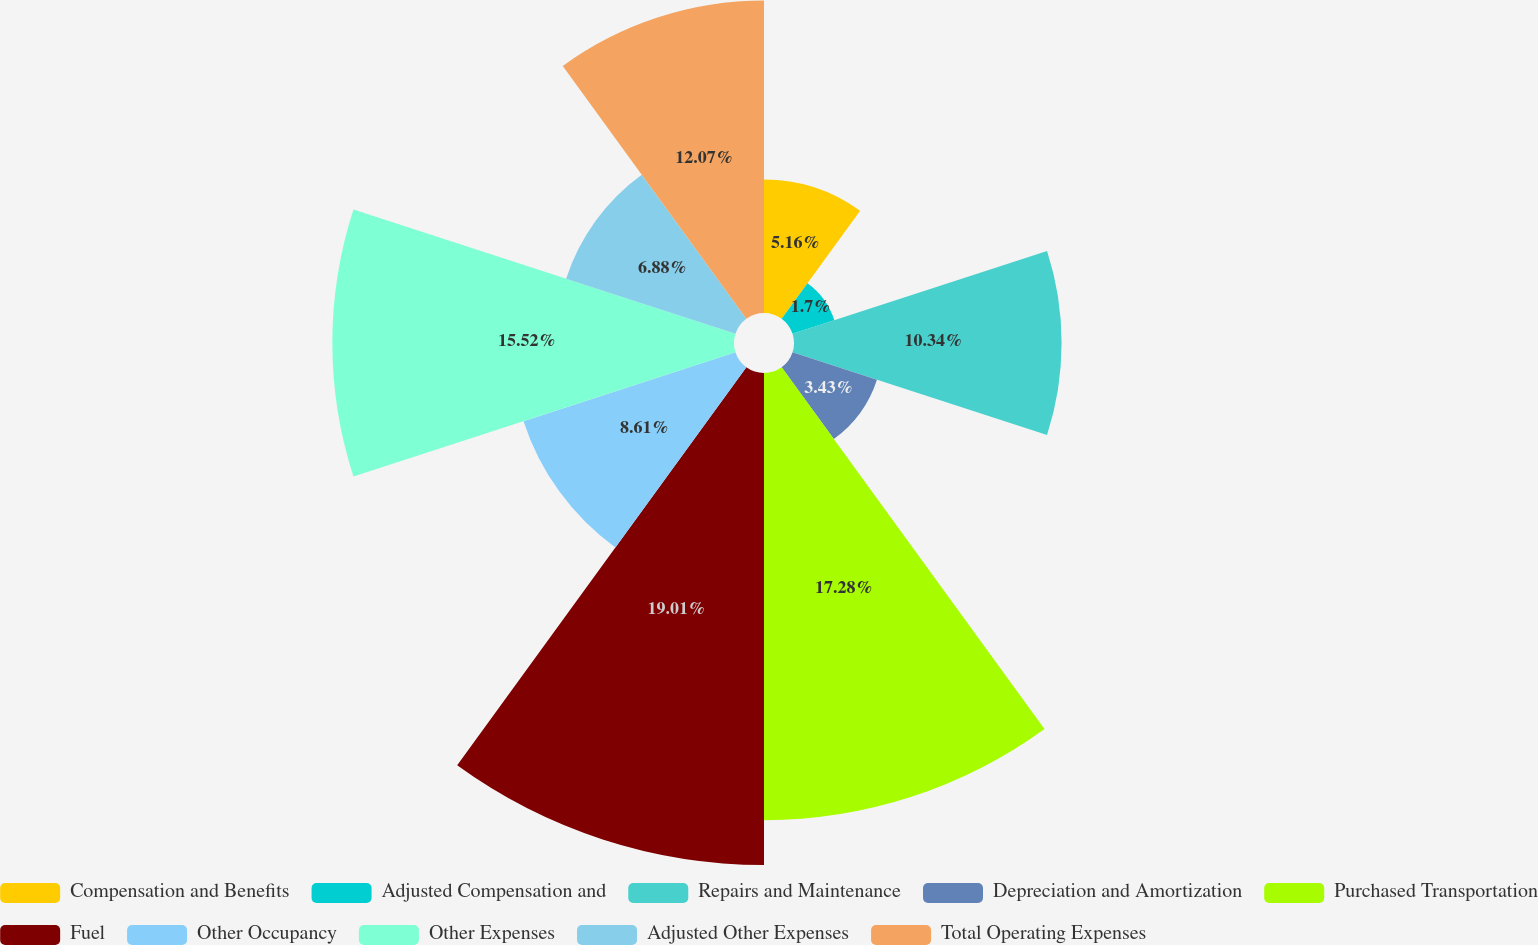<chart> <loc_0><loc_0><loc_500><loc_500><pie_chart><fcel>Compensation and Benefits<fcel>Adjusted Compensation and<fcel>Repairs and Maintenance<fcel>Depreciation and Amortization<fcel>Purchased Transportation<fcel>Fuel<fcel>Other Occupancy<fcel>Other Expenses<fcel>Adjusted Other Expenses<fcel>Total Operating Expenses<nl><fcel>5.16%<fcel>1.7%<fcel>10.34%<fcel>3.43%<fcel>17.28%<fcel>19.01%<fcel>8.61%<fcel>15.52%<fcel>6.88%<fcel>12.07%<nl></chart> 